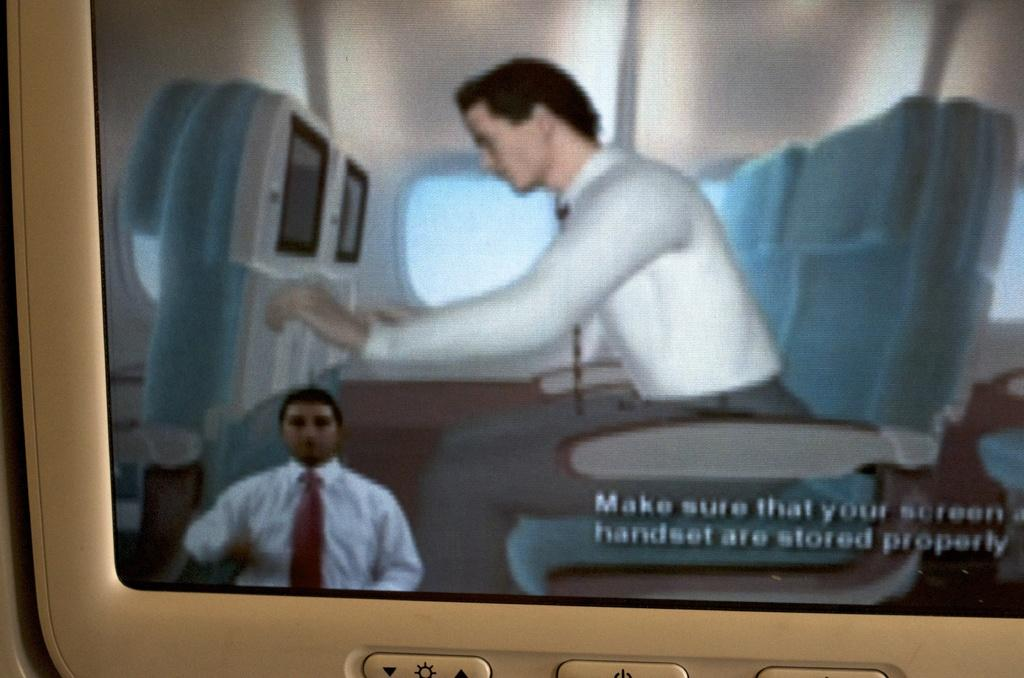What type of image is displayed on the screen? The image is an animated picture. What elements are present in the animated picture? The animated picture contains persons, machines, chairs, windows, a wall, and a roof. Where are the buttons located in the image? The buttons are at the bottom of the image. How does the animated picture depict the loss of a clover? The animated picture does not depict the loss of a clover, as it contains persons, machines, chairs, windows, a wall, and a roof, but no clover. 